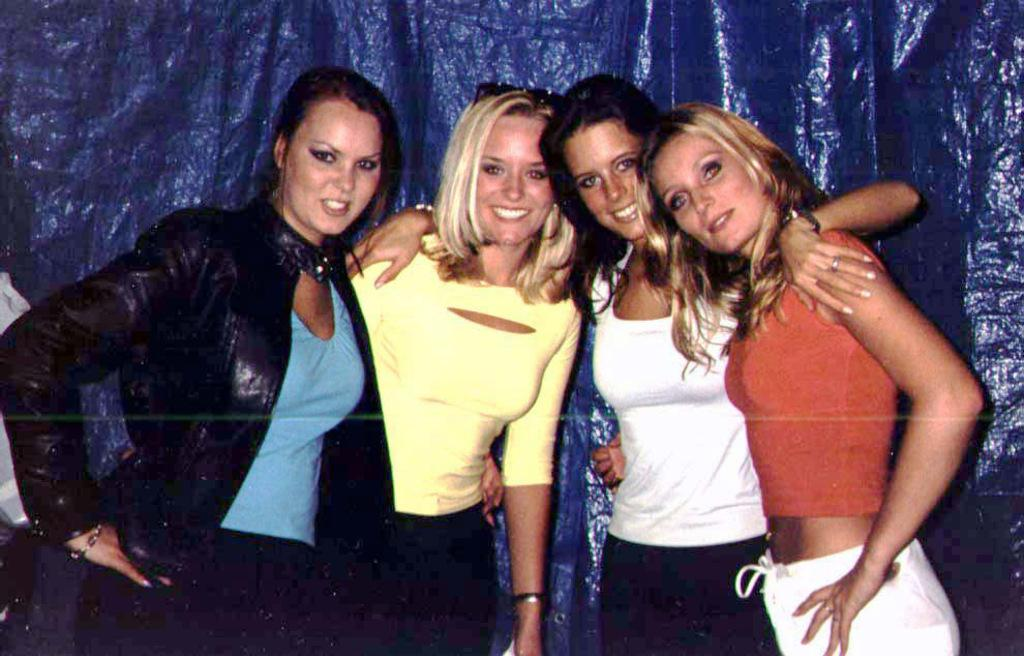How many people are in the image? There are persons standing in the image. What are the persons doing in the image? The persons are posing for a photo. Can you describe the curtain in the image? The curtain in the image looks like a plastic sheet. Where is the garden located in the image? There is no garden present in the image. What type of brush is being used by the persons in the image? There is no brush visible in the image; the persons are posing for a photo. 